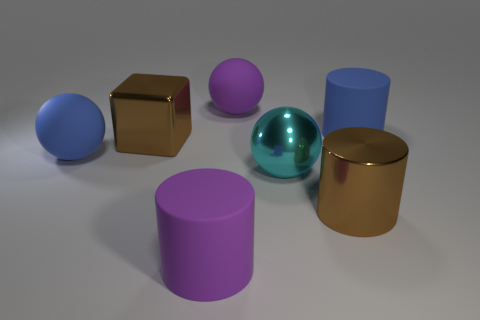Add 1 metallic balls. How many objects exist? 8 Subtract all cubes. How many objects are left? 6 Subtract 1 purple balls. How many objects are left? 6 Subtract all big yellow cubes. Subtract all blue objects. How many objects are left? 5 Add 5 big blue objects. How many big blue objects are left? 7 Add 2 large purple spheres. How many large purple spheres exist? 3 